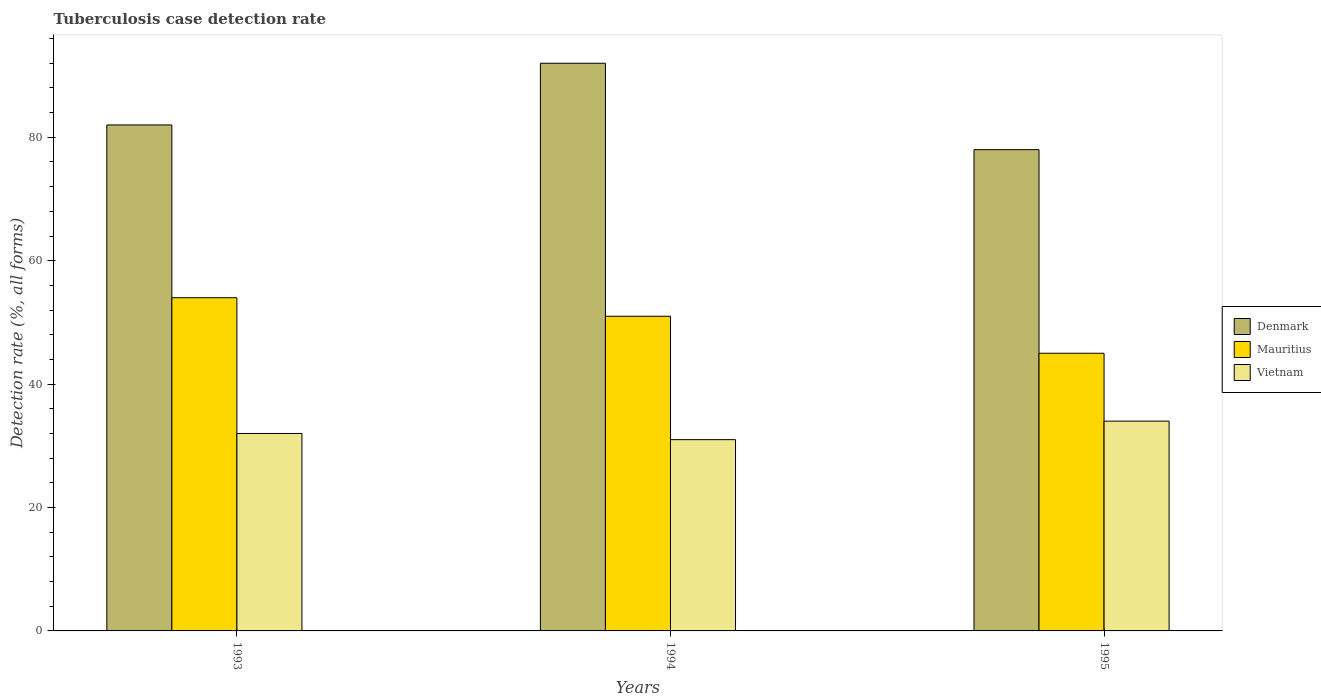How many groups of bars are there?
Provide a short and direct response. 3. Are the number of bars per tick equal to the number of legend labels?
Your answer should be very brief. Yes. Are the number of bars on each tick of the X-axis equal?
Your response must be concise. Yes. How many bars are there on the 1st tick from the left?
Offer a very short reply. 3. What is the label of the 3rd group of bars from the left?
Ensure brevity in your answer.  1995. In how many cases, is the number of bars for a given year not equal to the number of legend labels?
Offer a very short reply. 0. What is the tuberculosis case detection rate in in Mauritius in 1993?
Provide a succinct answer. 54. Across all years, what is the maximum tuberculosis case detection rate in in Denmark?
Give a very brief answer. 92. Across all years, what is the minimum tuberculosis case detection rate in in Denmark?
Your answer should be very brief. 78. In which year was the tuberculosis case detection rate in in Vietnam maximum?
Your response must be concise. 1995. What is the total tuberculosis case detection rate in in Vietnam in the graph?
Provide a short and direct response. 97. What is the difference between the tuberculosis case detection rate in in Vietnam in 1993 and that in 1995?
Your answer should be very brief. -2. What is the difference between the tuberculosis case detection rate in in Denmark in 1994 and the tuberculosis case detection rate in in Vietnam in 1995?
Your answer should be compact. 58. What is the average tuberculosis case detection rate in in Vietnam per year?
Your response must be concise. 32.33. In the year 1993, what is the difference between the tuberculosis case detection rate in in Vietnam and tuberculosis case detection rate in in Denmark?
Your answer should be very brief. -50. What is the ratio of the tuberculosis case detection rate in in Denmark in 1993 to that in 1995?
Make the answer very short. 1.05. What is the difference between the highest and the lowest tuberculosis case detection rate in in Denmark?
Offer a very short reply. 14. In how many years, is the tuberculosis case detection rate in in Mauritius greater than the average tuberculosis case detection rate in in Mauritius taken over all years?
Provide a short and direct response. 2. What does the 3rd bar from the left in 1995 represents?
Provide a succinct answer. Vietnam. What does the 1st bar from the right in 1994 represents?
Ensure brevity in your answer.  Vietnam. How many bars are there?
Your answer should be very brief. 9. Are the values on the major ticks of Y-axis written in scientific E-notation?
Ensure brevity in your answer.  No. Does the graph contain any zero values?
Provide a short and direct response. No. Does the graph contain grids?
Provide a succinct answer. No. Where does the legend appear in the graph?
Provide a short and direct response. Center right. How many legend labels are there?
Make the answer very short. 3. What is the title of the graph?
Your answer should be very brief. Tuberculosis case detection rate. What is the label or title of the X-axis?
Give a very brief answer. Years. What is the label or title of the Y-axis?
Your response must be concise. Detection rate (%, all forms). What is the Detection rate (%, all forms) in Denmark in 1994?
Give a very brief answer. 92. What is the Detection rate (%, all forms) of Vietnam in 1994?
Provide a short and direct response. 31. What is the Detection rate (%, all forms) of Denmark in 1995?
Ensure brevity in your answer.  78. What is the Detection rate (%, all forms) in Mauritius in 1995?
Provide a succinct answer. 45. What is the Detection rate (%, all forms) of Vietnam in 1995?
Offer a terse response. 34. Across all years, what is the maximum Detection rate (%, all forms) of Denmark?
Make the answer very short. 92. Across all years, what is the maximum Detection rate (%, all forms) of Vietnam?
Keep it short and to the point. 34. Across all years, what is the minimum Detection rate (%, all forms) in Denmark?
Offer a terse response. 78. Across all years, what is the minimum Detection rate (%, all forms) of Vietnam?
Your response must be concise. 31. What is the total Detection rate (%, all forms) in Denmark in the graph?
Make the answer very short. 252. What is the total Detection rate (%, all forms) of Mauritius in the graph?
Your answer should be very brief. 150. What is the total Detection rate (%, all forms) of Vietnam in the graph?
Give a very brief answer. 97. What is the difference between the Detection rate (%, all forms) in Denmark in 1993 and that in 1994?
Your answer should be compact. -10. What is the difference between the Detection rate (%, all forms) of Mauritius in 1993 and that in 1994?
Make the answer very short. 3. What is the difference between the Detection rate (%, all forms) in Vietnam in 1993 and that in 1994?
Offer a terse response. 1. What is the difference between the Detection rate (%, all forms) in Denmark in 1993 and that in 1995?
Provide a short and direct response. 4. What is the difference between the Detection rate (%, all forms) in Mauritius in 1993 and the Detection rate (%, all forms) in Vietnam in 1995?
Give a very brief answer. 20. What is the difference between the Detection rate (%, all forms) of Denmark in 1994 and the Detection rate (%, all forms) of Vietnam in 1995?
Offer a terse response. 58. What is the difference between the Detection rate (%, all forms) of Mauritius in 1994 and the Detection rate (%, all forms) of Vietnam in 1995?
Your response must be concise. 17. What is the average Detection rate (%, all forms) in Denmark per year?
Make the answer very short. 84. What is the average Detection rate (%, all forms) in Vietnam per year?
Your response must be concise. 32.33. In the year 1993, what is the difference between the Detection rate (%, all forms) of Denmark and Detection rate (%, all forms) of Mauritius?
Provide a short and direct response. 28. In the year 1993, what is the difference between the Detection rate (%, all forms) of Mauritius and Detection rate (%, all forms) of Vietnam?
Provide a succinct answer. 22. In the year 1994, what is the difference between the Detection rate (%, all forms) in Denmark and Detection rate (%, all forms) in Mauritius?
Keep it short and to the point. 41. In the year 1994, what is the difference between the Detection rate (%, all forms) of Denmark and Detection rate (%, all forms) of Vietnam?
Provide a succinct answer. 61. In the year 1994, what is the difference between the Detection rate (%, all forms) of Mauritius and Detection rate (%, all forms) of Vietnam?
Provide a succinct answer. 20. In the year 1995, what is the difference between the Detection rate (%, all forms) in Denmark and Detection rate (%, all forms) in Vietnam?
Offer a terse response. 44. In the year 1995, what is the difference between the Detection rate (%, all forms) in Mauritius and Detection rate (%, all forms) in Vietnam?
Ensure brevity in your answer.  11. What is the ratio of the Detection rate (%, all forms) of Denmark in 1993 to that in 1994?
Provide a succinct answer. 0.89. What is the ratio of the Detection rate (%, all forms) of Mauritius in 1993 to that in 1994?
Offer a terse response. 1.06. What is the ratio of the Detection rate (%, all forms) of Vietnam in 1993 to that in 1994?
Ensure brevity in your answer.  1.03. What is the ratio of the Detection rate (%, all forms) in Denmark in 1993 to that in 1995?
Give a very brief answer. 1.05. What is the ratio of the Detection rate (%, all forms) in Vietnam in 1993 to that in 1995?
Keep it short and to the point. 0.94. What is the ratio of the Detection rate (%, all forms) in Denmark in 1994 to that in 1995?
Keep it short and to the point. 1.18. What is the ratio of the Detection rate (%, all forms) of Mauritius in 1994 to that in 1995?
Provide a short and direct response. 1.13. What is the ratio of the Detection rate (%, all forms) in Vietnam in 1994 to that in 1995?
Give a very brief answer. 0.91. What is the difference between the highest and the second highest Detection rate (%, all forms) in Mauritius?
Give a very brief answer. 3. What is the difference between the highest and the second highest Detection rate (%, all forms) in Vietnam?
Your response must be concise. 2. 